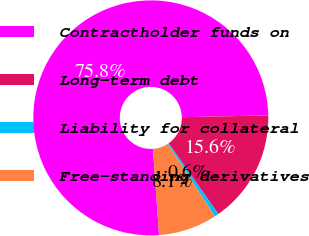<chart> <loc_0><loc_0><loc_500><loc_500><pie_chart><fcel>Contractholder funds on<fcel>Long-term debt<fcel>Liability for collateral<fcel>Free-standing derivatives<nl><fcel>75.78%<fcel>15.6%<fcel>0.55%<fcel>8.07%<nl></chart> 